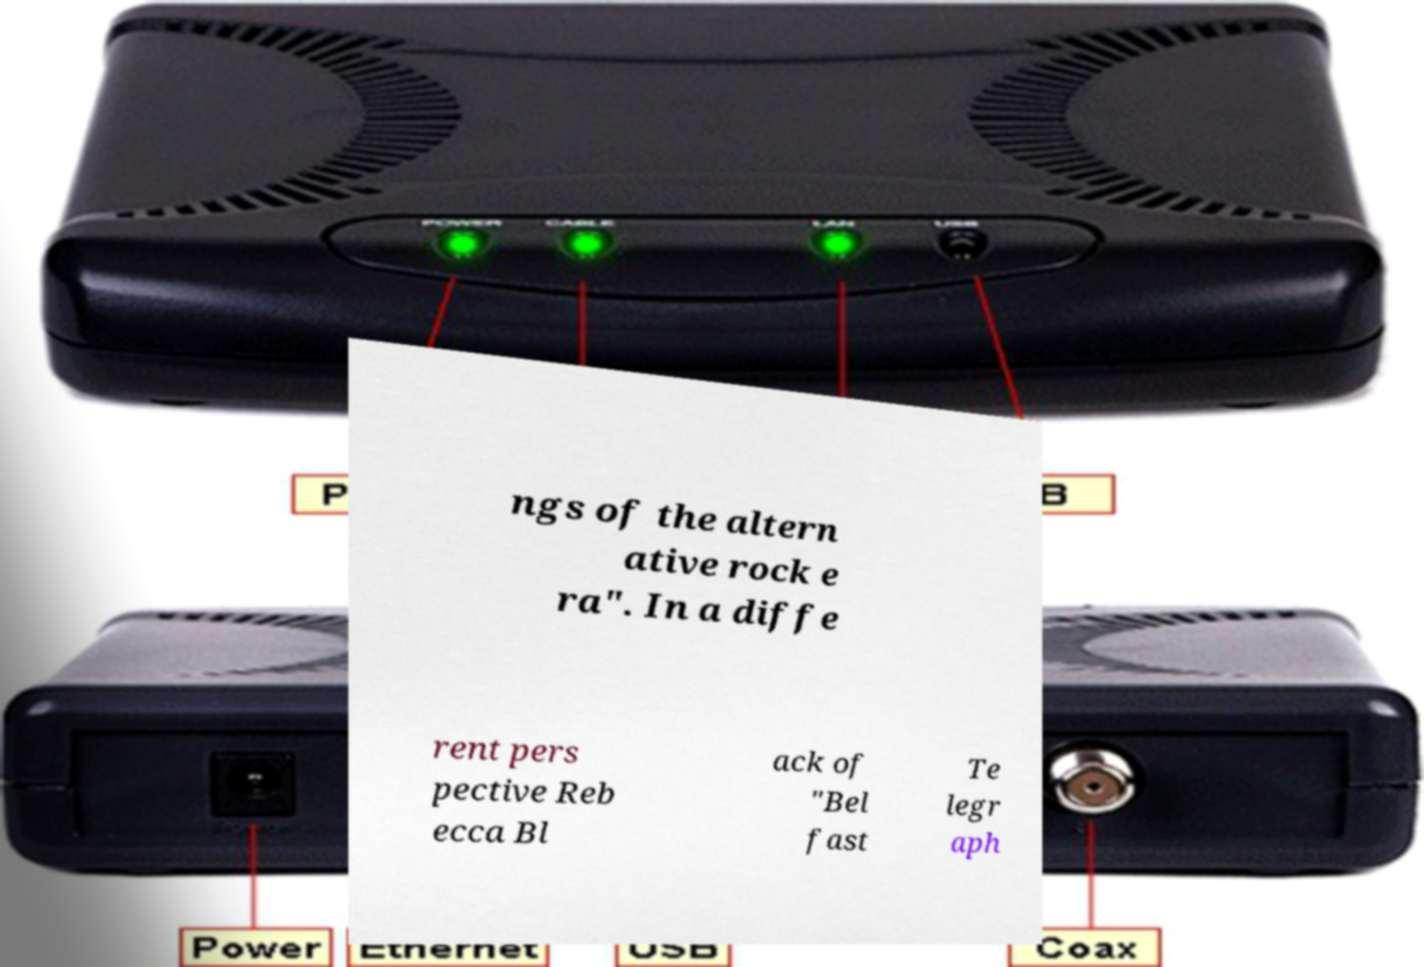Can you read and provide the text displayed in the image?This photo seems to have some interesting text. Can you extract and type it out for me? ngs of the altern ative rock e ra". In a diffe rent pers pective Reb ecca Bl ack of "Bel fast Te legr aph 